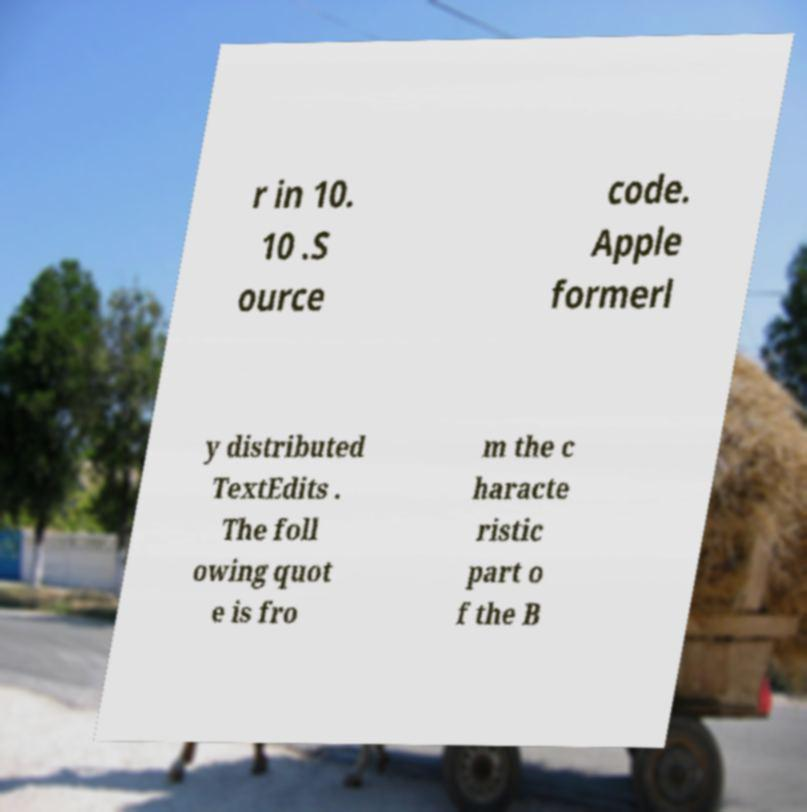For documentation purposes, I need the text within this image transcribed. Could you provide that? r in 10. 10 .S ource code. Apple formerl y distributed TextEdits . The foll owing quot e is fro m the c haracte ristic part o f the B 